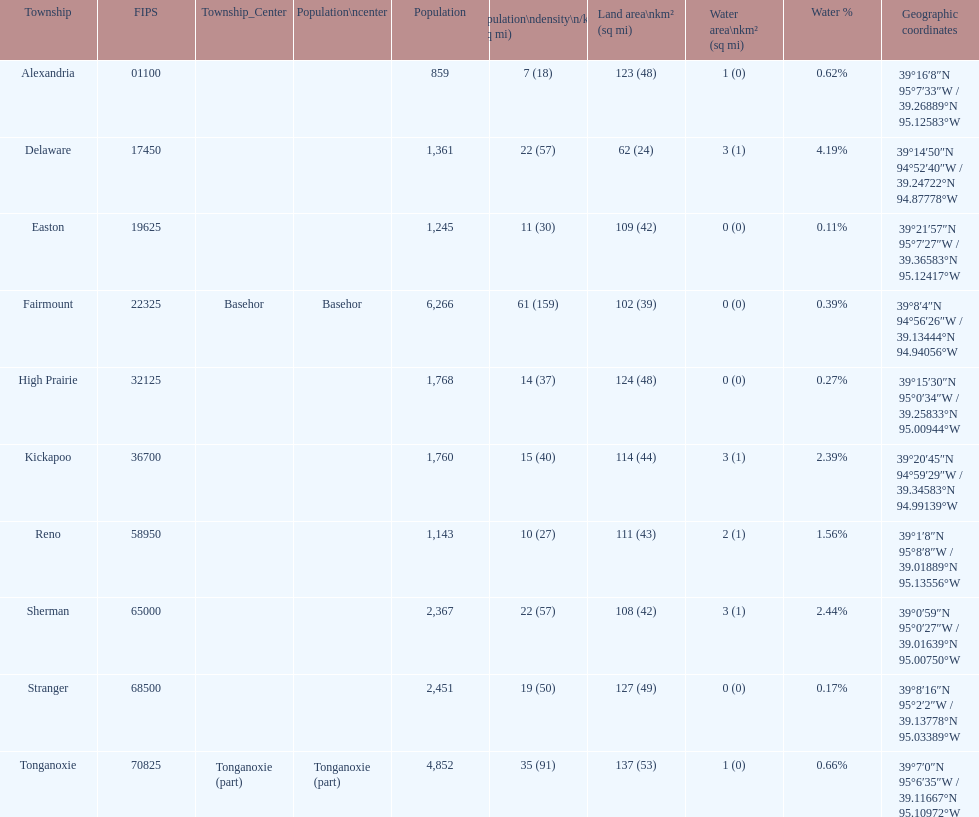Which township has the least land area? Delaware. Would you be able to parse every entry in this table? {'header': ['Township', 'FIPS', 'Township_Center', 'Population\\ncenter', 'Population', 'Population\\ndensity\\n/km² (/sq\xa0mi)', 'Land area\\nkm² (sq\xa0mi)', 'Water area\\nkm² (sq\xa0mi)', 'Water\xa0%', 'Geographic coordinates'], 'rows': [['Alexandria', '01100', '', '', '859', '7 (18)', '123 (48)', '1 (0)', '0.62%', '39°16′8″N 95°7′33″W\ufeff / \ufeff39.26889°N 95.12583°W'], ['Delaware', '17450', '', '', '1,361', '22 (57)', '62 (24)', '3 (1)', '4.19%', '39°14′50″N 94°52′40″W\ufeff / \ufeff39.24722°N 94.87778°W'], ['Easton', '19625', '', '', '1,245', '11 (30)', '109 (42)', '0 (0)', '0.11%', '39°21′57″N 95°7′27″W\ufeff / \ufeff39.36583°N 95.12417°W'], ['Fairmount', '22325', 'Basehor', 'Basehor', '6,266', '61 (159)', '102 (39)', '0 (0)', '0.39%', '39°8′4″N 94°56′26″W\ufeff / \ufeff39.13444°N 94.94056°W'], ['High Prairie', '32125', '', '', '1,768', '14 (37)', '124 (48)', '0 (0)', '0.27%', '39°15′30″N 95°0′34″W\ufeff / \ufeff39.25833°N 95.00944°W'], ['Kickapoo', '36700', '', '', '1,760', '15 (40)', '114 (44)', '3 (1)', '2.39%', '39°20′45″N 94°59′29″W\ufeff / \ufeff39.34583°N 94.99139°W'], ['Reno', '58950', '', '', '1,143', '10 (27)', '111 (43)', '2 (1)', '1.56%', '39°1′8″N 95°8′8″W\ufeff / \ufeff39.01889°N 95.13556°W'], ['Sherman', '65000', '', '', '2,367', '22 (57)', '108 (42)', '3 (1)', '2.44%', '39°0′59″N 95°0′27″W\ufeff / \ufeff39.01639°N 95.00750°W'], ['Stranger', '68500', '', '', '2,451', '19 (50)', '127 (49)', '0 (0)', '0.17%', '39°8′16″N 95°2′2″W\ufeff / \ufeff39.13778°N 95.03389°W'], ['Tonganoxie', '70825', 'Tonganoxie (part)', 'Tonganoxie (part)', '4,852', '35 (91)', '137 (53)', '1 (0)', '0.66%', '39°7′0″N 95°6′35″W\ufeff / \ufeff39.11667°N 95.10972°W']]} 